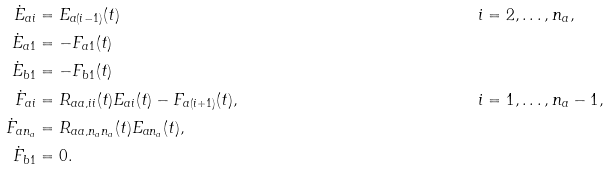Convert formula to latex. <formula><loc_0><loc_0><loc_500><loc_500>\dot { E } _ { a i } & = E _ { a ( i - 1 ) } ( t ) & i & = 2 , \dots , n _ { a } , \\ \dot { E } _ { a 1 } & = - F _ { a 1 } ( t ) & & \\ \dot { E } _ { b 1 } & = - F _ { b 1 } ( t ) & & \\ \dot { F } _ { a i } & = R _ { a a , i i } ( t ) E _ { a i } ( t ) - F _ { a ( i + 1 ) } ( t ) , & i & = 1 , \dots , n _ { a } - 1 , \\ \dot { F } _ { a n _ { a } } & = R _ { a a , n _ { a } n _ { a } } ( t ) E _ { a n _ { a } } ( t ) , & & \\ \dot { F } _ { b 1 } & = 0 . & &</formula> 